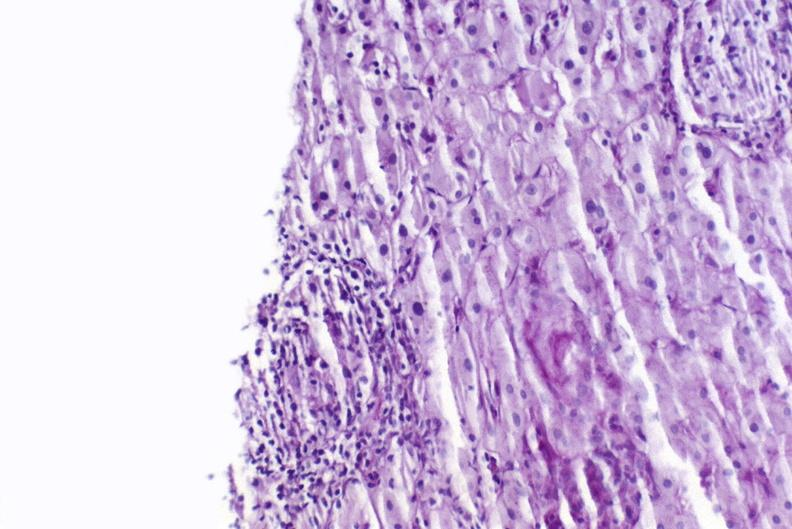does surface show sarcoid?
Answer the question using a single word or phrase. No 